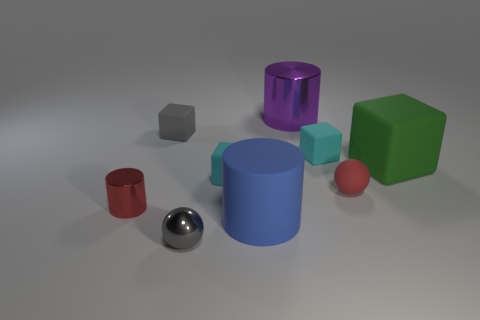What material is the thing that is the same color as the metal sphere?
Make the answer very short. Rubber. What is the material of the purple cylinder that is the same size as the green object?
Keep it short and to the point. Metal. Is the large block made of the same material as the small gray block?
Your answer should be compact. Yes. What is the color of the small sphere that is the same material as the large blue cylinder?
Your response must be concise. Red. There is a blue object that is the same shape as the red metallic thing; what material is it?
Ensure brevity in your answer.  Rubber. What material is the large thing that is behind the large blue rubber cylinder and in front of the big metallic object?
Your response must be concise. Rubber. What is the shape of the small gray thing that is the same material as the green block?
Offer a terse response. Cube. The other cylinder that is the same material as the purple cylinder is what size?
Give a very brief answer. Small. The matte object that is on the left side of the large purple thing and behind the big rubber block has what shape?
Offer a very short reply. Cube. There is a cyan rubber cube that is behind the big matte thing that is behind the large blue rubber thing; what size is it?
Offer a very short reply. Small. 